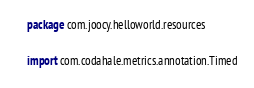<code> <loc_0><loc_0><loc_500><loc_500><_Kotlin_>package com.joocy.helloworld.resources

import com.codahale.metrics.annotation.Timed</code> 